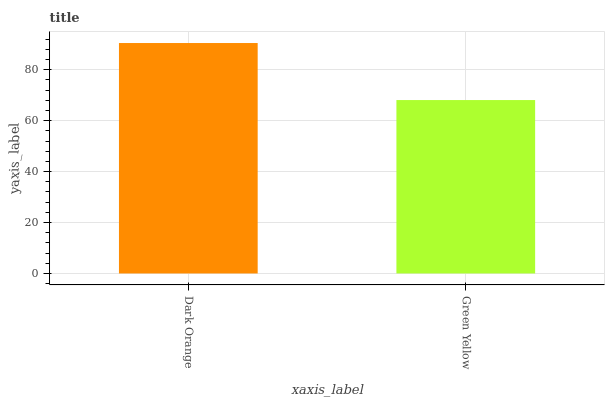Is Green Yellow the minimum?
Answer yes or no. Yes. Is Dark Orange the maximum?
Answer yes or no. Yes. Is Green Yellow the maximum?
Answer yes or no. No. Is Dark Orange greater than Green Yellow?
Answer yes or no. Yes. Is Green Yellow less than Dark Orange?
Answer yes or no. Yes. Is Green Yellow greater than Dark Orange?
Answer yes or no. No. Is Dark Orange less than Green Yellow?
Answer yes or no. No. Is Dark Orange the high median?
Answer yes or no. Yes. Is Green Yellow the low median?
Answer yes or no. Yes. Is Green Yellow the high median?
Answer yes or no. No. Is Dark Orange the low median?
Answer yes or no. No. 